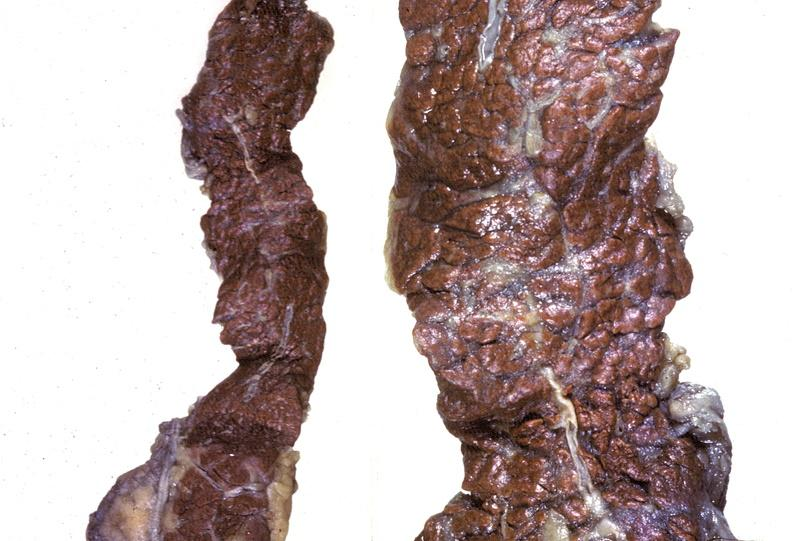does coronary artery show pancreas, hemochromatosis?
Answer the question using a single word or phrase. No 